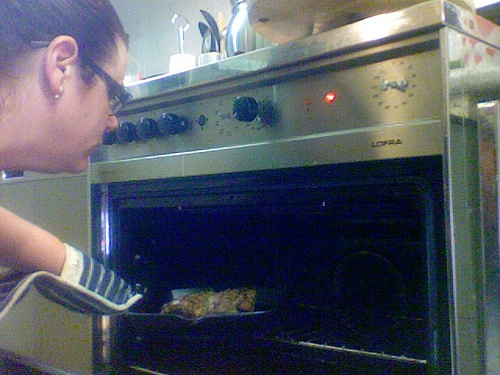Describe the objects in this image and their specific colors. I can see oven in gray, black, navy, and olive tones and people in gray, lightpink, and darkgray tones in this image. 